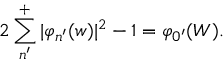Convert formula to latex. <formula><loc_0><loc_0><loc_500><loc_500>2 \sum _ { n ^ { \prime } } ^ { + } | \varphi _ { n ^ { \prime } } ( w ) | ^ { 2 } - 1 = \varphi _ { 0 ^ { \prime } } ( W ) .</formula> 